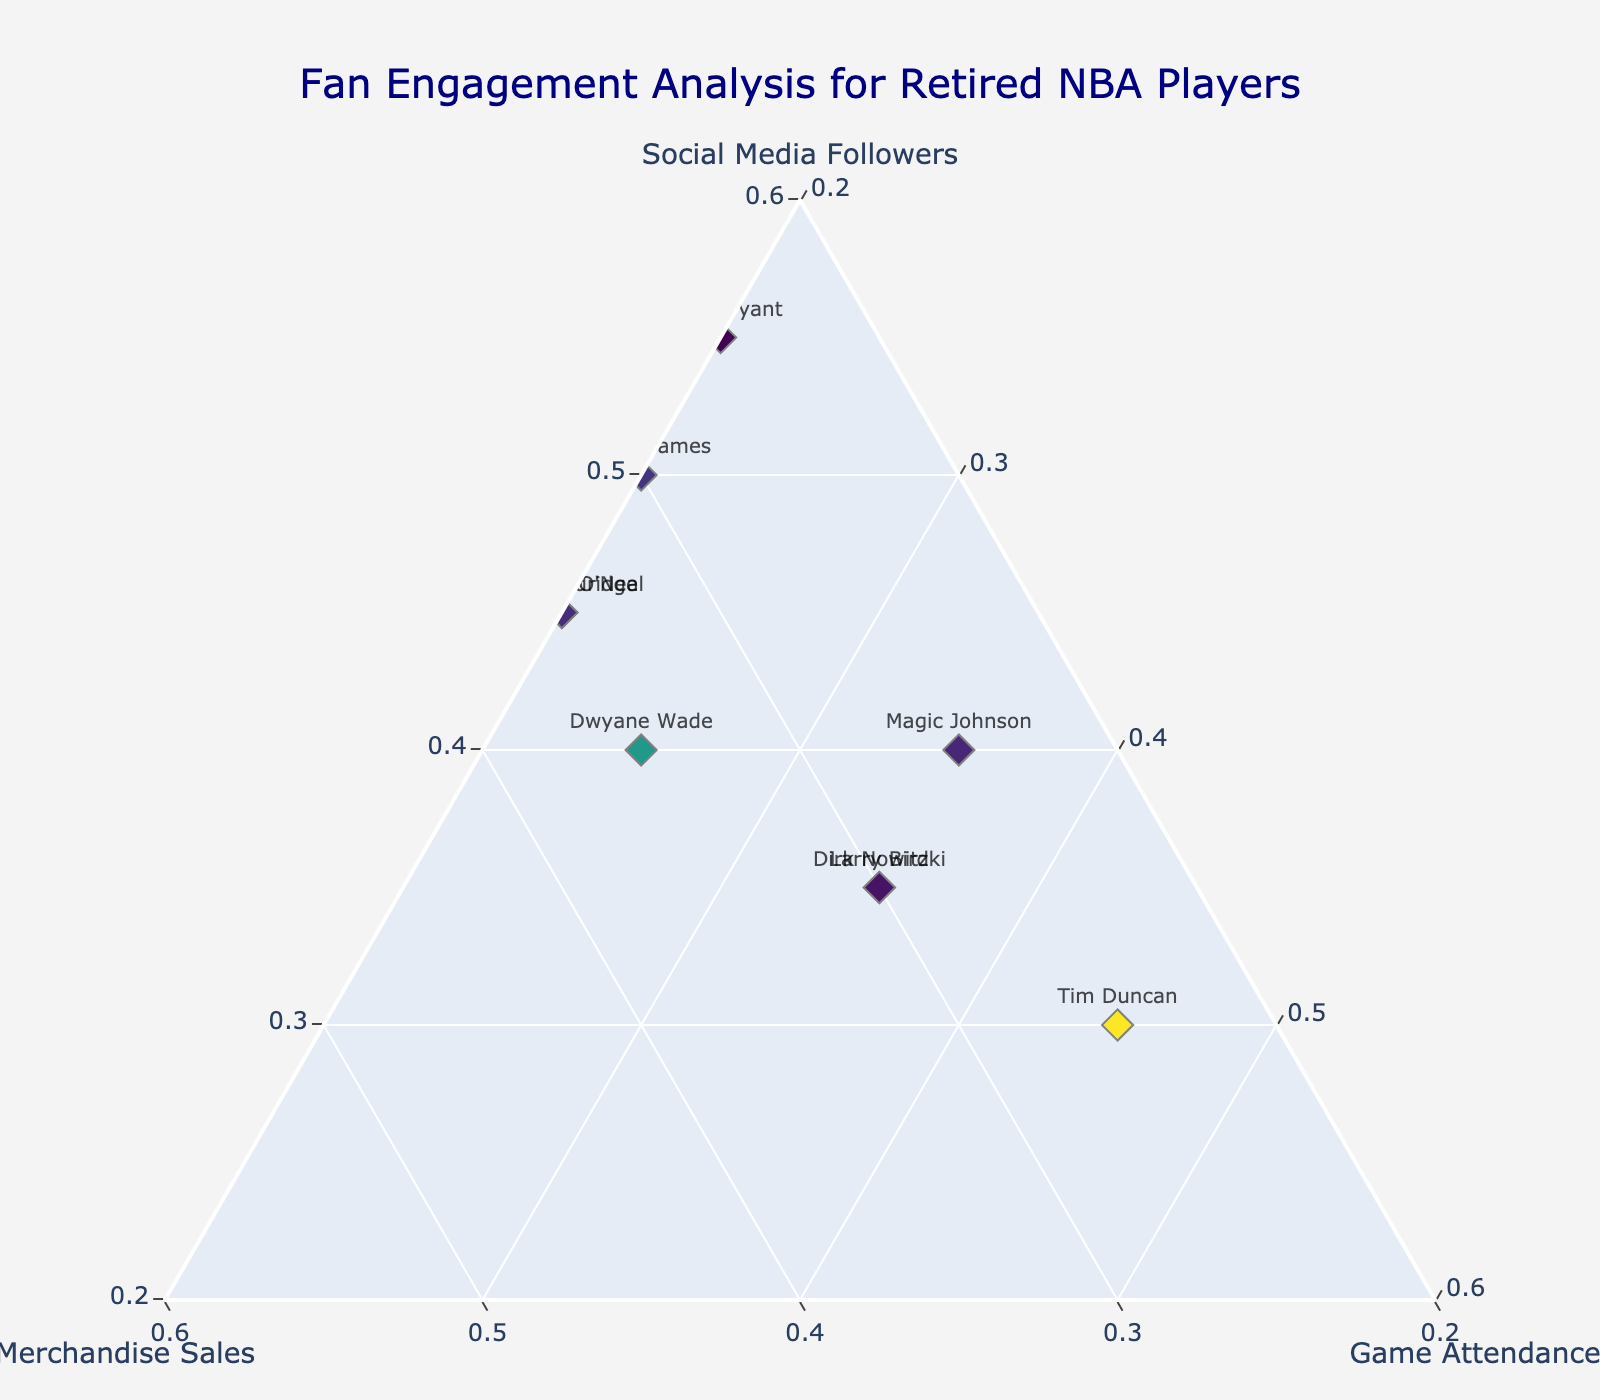What is the title of the plot? The title is usually found at the top of the plot and serves as a description of what the plot represents. In this case, it says "Fan Engagement Analysis for Retired NBA Players".
Answer: Fan Engagement Analysis for Retired NBA Players Which axis represents merchandise sales? In a ternary plot, each vertex of the triangle represents one of the three components. The axis describing "Merchandise Sales" would be labeled at one of the three vertex points.
Answer: The b-axis What player has the highest social media followers? To identify this player, look for the point closest to the vertex labeled "Social Media Followers".
Answer: Michael Jordan Which two players have equal game attendance percentages? By examining the distance of each point from the vertex labeled "Game Attendance", we can determine that Magic Johnson and Larry Bird both have points that are equidistant from this vertex.
Answer: Magic Johnson and Larry Bird What is the sum of the social media followers, merchandise sales, and game attendance for LeBron James? For each player, the three values should sum to 1 because they represent proportions of a whole. Checking LeBron James data: 0.50 (followers) + 0.30 (sales) + 0.20 (attendance) = 1.00.
Answer: 1.00 Who has a higher engagement in merchandise sales, Dwyane Wade or Kobe Bryant? Compare the position of Dwyane Wade and Kobe Bryant on the axis labeled "Merchandise Sales". Dwyane Wade's point is closer to the vertex, representing a higher engagement in this area.
Answer: Dwyane Wade Which player shows an equal split between merchandise sales and game attendance? Analyzing the points' distance from both the "Merchandise Sales" and "Game Attendance" vertices, the player closest to the middle of these axes with equal proportions is Dirk Nowitzki.
Answer: Dirk Nowitzki What is the average social media followers percentage for Archie Aldridge, Shaquille O'Neal, and Dwyane Wade? First, get the social media followers percentages: Archie Aldridge (0.45), Shaquille O'Neal (0.45), and Dwyane Wade (0.40). Then, sum these values and divide by 3: (0.45 + 0.45 + 0.40) / 3 = 0.4333.
Answer: 0.4333 Which three players have the highest game attendance percentages? Checking the distances from the vertex labeled "Game Attendance", the three players furthest from this vertex are Tim Duncan (0.45), Magic Johnson (0.35), and Larry Bird (0.35).
Answer: Tim Duncan, Magic Johnson, Larry Bird 